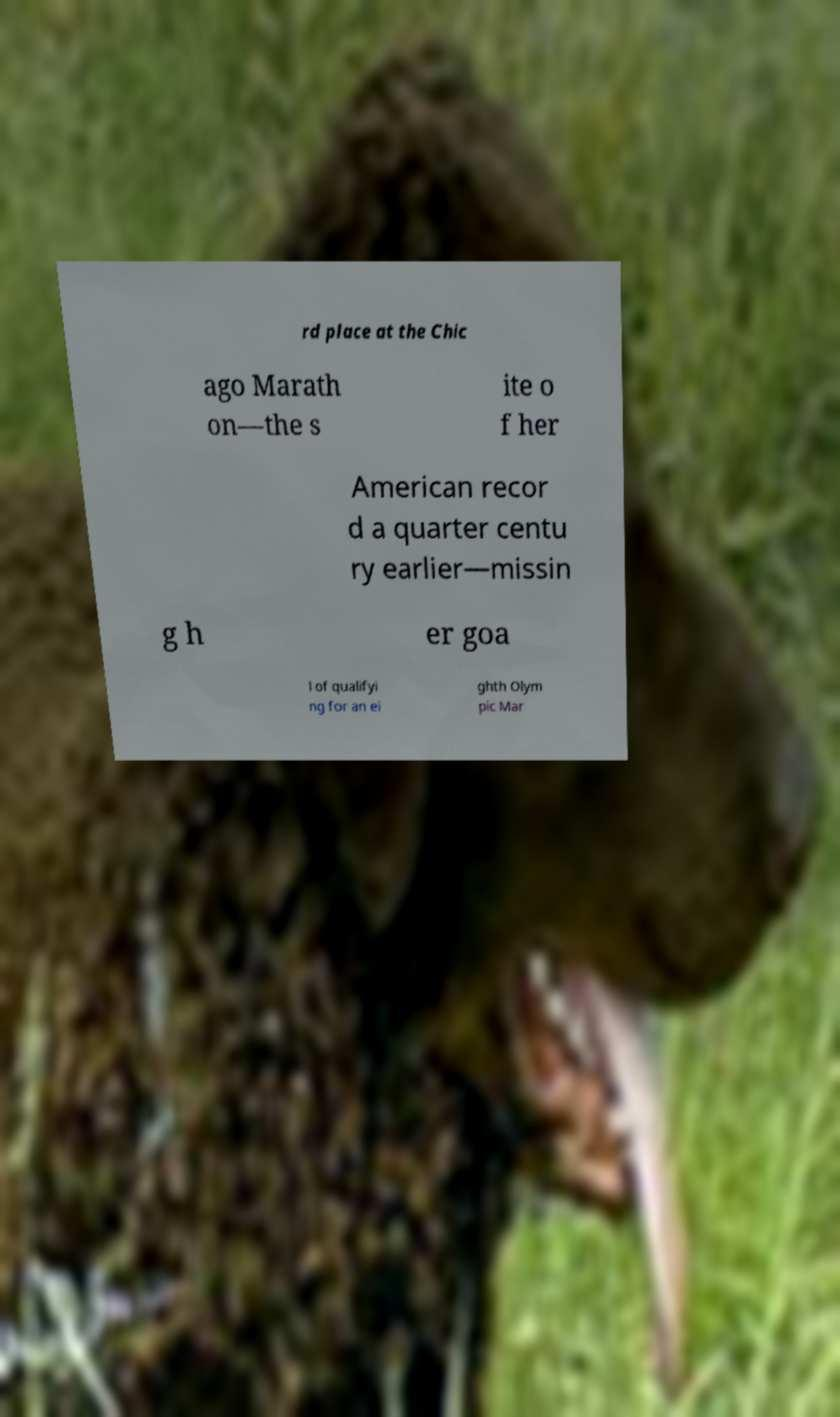Can you read and provide the text displayed in the image?This photo seems to have some interesting text. Can you extract and type it out for me? rd place at the Chic ago Marath on—the s ite o f her American recor d a quarter centu ry earlier—missin g h er goa l of qualifyi ng for an ei ghth Olym pic Mar 